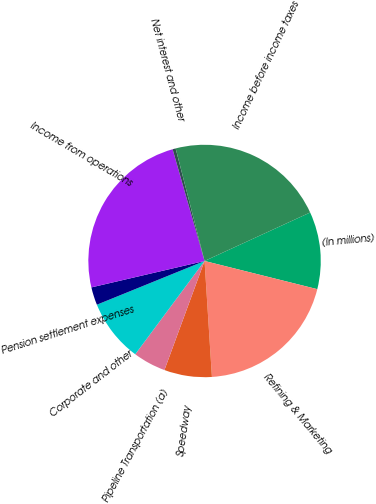Convert chart. <chart><loc_0><loc_0><loc_500><loc_500><pie_chart><fcel>(In millions)<fcel>Refining & Marketing<fcel>Speedway<fcel>Pipeline Transportation (a)<fcel>Corporate and other<fcel>Pension settlement expenses<fcel>Income from operations<fcel>Net interest and other<fcel>Income before income taxes<nl><fcel>10.75%<fcel>20.09%<fcel>6.62%<fcel>4.56%<fcel>8.69%<fcel>2.49%<fcel>24.22%<fcel>0.43%<fcel>22.15%<nl></chart> 